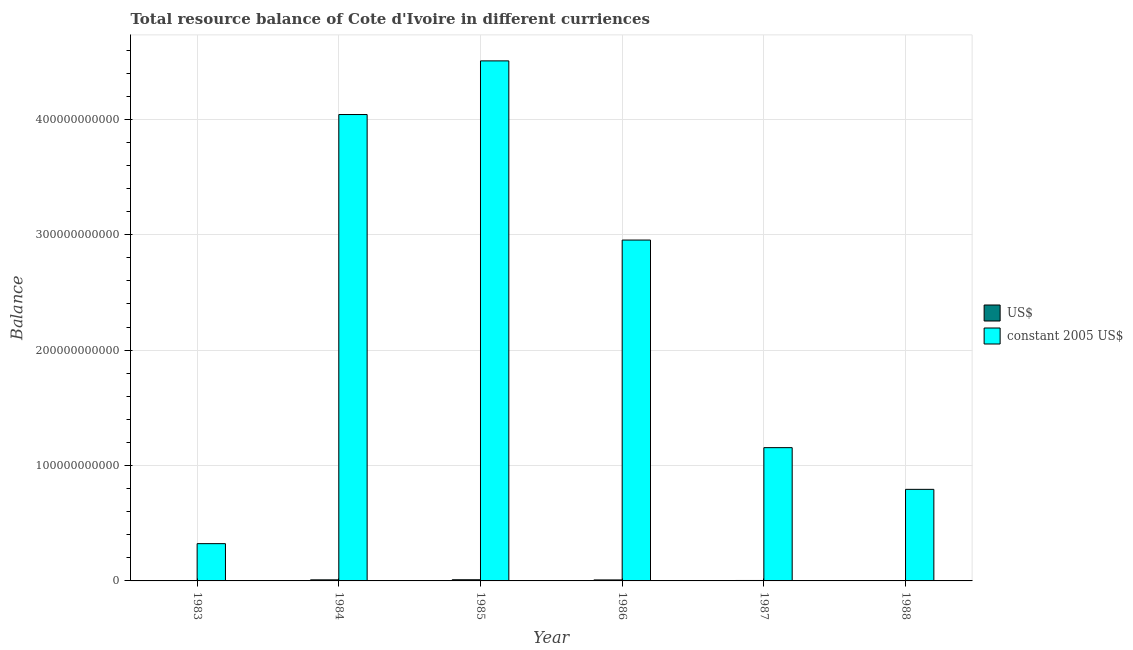How many different coloured bars are there?
Make the answer very short. 2. How many groups of bars are there?
Keep it short and to the point. 6. Are the number of bars on each tick of the X-axis equal?
Keep it short and to the point. Yes. How many bars are there on the 1st tick from the left?
Provide a short and direct response. 2. What is the label of the 1st group of bars from the left?
Make the answer very short. 1983. What is the resource balance in us$ in 1983?
Provide a succinct answer. 8.48e+07. Across all years, what is the maximum resource balance in constant us$?
Keep it short and to the point. 4.51e+11. Across all years, what is the minimum resource balance in constant us$?
Offer a very short reply. 3.23e+1. In which year was the resource balance in constant us$ minimum?
Offer a very short reply. 1983. What is the total resource balance in constant us$ in the graph?
Offer a terse response. 1.38e+12. What is the difference between the resource balance in constant us$ in 1983 and that in 1987?
Your response must be concise. -8.32e+1. What is the difference between the resource balance in us$ in 1986 and the resource balance in constant us$ in 1983?
Offer a terse response. 7.68e+08. What is the average resource balance in us$ per year?
Provide a succinct answer. 5.86e+08. What is the ratio of the resource balance in constant us$ in 1985 to that in 1986?
Provide a succinct answer. 1.53. Is the resource balance in us$ in 1984 less than that in 1986?
Your answer should be very brief. No. Is the difference between the resource balance in us$ in 1984 and 1987 greater than the difference between the resource balance in constant us$ in 1984 and 1987?
Provide a short and direct response. No. What is the difference between the highest and the second highest resource balance in us$?
Ensure brevity in your answer.  7.82e+07. What is the difference between the highest and the lowest resource balance in us$?
Your answer should be very brief. 9.18e+08. Is the sum of the resource balance in constant us$ in 1984 and 1985 greater than the maximum resource balance in us$ across all years?
Provide a short and direct response. Yes. What does the 1st bar from the left in 1984 represents?
Your response must be concise. US$. What does the 2nd bar from the right in 1987 represents?
Provide a short and direct response. US$. How many bars are there?
Provide a short and direct response. 12. How many years are there in the graph?
Keep it short and to the point. 6. What is the difference between two consecutive major ticks on the Y-axis?
Provide a succinct answer. 1.00e+11. Are the values on the major ticks of Y-axis written in scientific E-notation?
Make the answer very short. No. How many legend labels are there?
Offer a very short reply. 2. How are the legend labels stacked?
Keep it short and to the point. Vertical. What is the title of the graph?
Offer a very short reply. Total resource balance of Cote d'Ivoire in different curriences. What is the label or title of the Y-axis?
Your answer should be compact. Balance. What is the Balance in US$ in 1983?
Your answer should be very brief. 8.48e+07. What is the Balance of constant 2005 US$ in 1983?
Your answer should be very brief. 3.23e+1. What is the Balance in US$ in 1984?
Offer a very short reply. 9.25e+08. What is the Balance of constant 2005 US$ in 1984?
Keep it short and to the point. 4.04e+11. What is the Balance of US$ in 1985?
Make the answer very short. 1.00e+09. What is the Balance of constant 2005 US$ in 1985?
Your response must be concise. 4.51e+11. What is the Balance in US$ in 1986?
Your answer should be compact. 8.53e+08. What is the Balance of constant 2005 US$ in 1986?
Your response must be concise. 2.95e+11. What is the Balance in US$ in 1987?
Your response must be concise. 3.84e+08. What is the Balance in constant 2005 US$ in 1987?
Make the answer very short. 1.15e+11. What is the Balance of US$ in 1988?
Offer a very short reply. 2.66e+08. What is the Balance of constant 2005 US$ in 1988?
Ensure brevity in your answer.  7.94e+1. Across all years, what is the maximum Balance of US$?
Your response must be concise. 1.00e+09. Across all years, what is the maximum Balance in constant 2005 US$?
Ensure brevity in your answer.  4.51e+11. Across all years, what is the minimum Balance in US$?
Provide a succinct answer. 8.48e+07. Across all years, what is the minimum Balance of constant 2005 US$?
Give a very brief answer. 3.23e+1. What is the total Balance in US$ in the graph?
Ensure brevity in your answer.  3.52e+09. What is the total Balance of constant 2005 US$ in the graph?
Your response must be concise. 1.38e+12. What is the difference between the Balance of US$ in 1983 and that in 1984?
Your response must be concise. -8.40e+08. What is the difference between the Balance of constant 2005 US$ in 1983 and that in 1984?
Provide a short and direct response. -3.72e+11. What is the difference between the Balance in US$ in 1983 and that in 1985?
Give a very brief answer. -9.18e+08. What is the difference between the Balance in constant 2005 US$ in 1983 and that in 1985?
Provide a short and direct response. -4.18e+11. What is the difference between the Balance in US$ in 1983 and that in 1986?
Provide a short and direct response. -7.68e+08. What is the difference between the Balance of constant 2005 US$ in 1983 and that in 1986?
Keep it short and to the point. -2.63e+11. What is the difference between the Balance of US$ in 1983 and that in 1987?
Keep it short and to the point. -3.00e+08. What is the difference between the Balance of constant 2005 US$ in 1983 and that in 1987?
Keep it short and to the point. -8.32e+1. What is the difference between the Balance in US$ in 1983 and that in 1988?
Ensure brevity in your answer.  -1.82e+08. What is the difference between the Balance in constant 2005 US$ in 1983 and that in 1988?
Your answer should be compact. -4.71e+1. What is the difference between the Balance of US$ in 1984 and that in 1985?
Ensure brevity in your answer.  -7.82e+07. What is the difference between the Balance in constant 2005 US$ in 1984 and that in 1985?
Offer a terse response. -4.65e+1. What is the difference between the Balance in US$ in 1984 and that in 1986?
Your answer should be compact. 7.20e+07. What is the difference between the Balance of constant 2005 US$ in 1984 and that in 1986?
Your answer should be compact. 1.09e+11. What is the difference between the Balance of US$ in 1984 and that in 1987?
Offer a very short reply. 5.41e+08. What is the difference between the Balance of constant 2005 US$ in 1984 and that in 1987?
Ensure brevity in your answer.  2.89e+11. What is the difference between the Balance of US$ in 1984 and that in 1988?
Provide a succinct answer. 6.59e+08. What is the difference between the Balance in constant 2005 US$ in 1984 and that in 1988?
Keep it short and to the point. 3.25e+11. What is the difference between the Balance in US$ in 1985 and that in 1986?
Give a very brief answer. 1.50e+08. What is the difference between the Balance of constant 2005 US$ in 1985 and that in 1986?
Offer a very short reply. 1.55e+11. What is the difference between the Balance in US$ in 1985 and that in 1987?
Your answer should be very brief. 6.19e+08. What is the difference between the Balance of constant 2005 US$ in 1985 and that in 1987?
Your response must be concise. 3.35e+11. What is the difference between the Balance in US$ in 1985 and that in 1988?
Provide a short and direct response. 7.37e+08. What is the difference between the Balance of constant 2005 US$ in 1985 and that in 1988?
Offer a very short reply. 3.71e+11. What is the difference between the Balance in US$ in 1986 and that in 1987?
Make the answer very short. 4.69e+08. What is the difference between the Balance of constant 2005 US$ in 1986 and that in 1987?
Ensure brevity in your answer.  1.80e+11. What is the difference between the Balance in US$ in 1986 and that in 1988?
Provide a short and direct response. 5.87e+08. What is the difference between the Balance in constant 2005 US$ in 1986 and that in 1988?
Give a very brief answer. 2.16e+11. What is the difference between the Balance of US$ in 1987 and that in 1988?
Keep it short and to the point. 1.18e+08. What is the difference between the Balance in constant 2005 US$ in 1987 and that in 1988?
Your answer should be very brief. 3.61e+1. What is the difference between the Balance in US$ in 1983 and the Balance in constant 2005 US$ in 1984?
Your answer should be very brief. -4.04e+11. What is the difference between the Balance in US$ in 1983 and the Balance in constant 2005 US$ in 1985?
Provide a succinct answer. -4.51e+11. What is the difference between the Balance in US$ in 1983 and the Balance in constant 2005 US$ in 1986?
Offer a terse response. -2.95e+11. What is the difference between the Balance in US$ in 1983 and the Balance in constant 2005 US$ in 1987?
Your response must be concise. -1.15e+11. What is the difference between the Balance in US$ in 1983 and the Balance in constant 2005 US$ in 1988?
Provide a short and direct response. -7.93e+1. What is the difference between the Balance of US$ in 1984 and the Balance of constant 2005 US$ in 1985?
Keep it short and to the point. -4.50e+11. What is the difference between the Balance of US$ in 1984 and the Balance of constant 2005 US$ in 1986?
Give a very brief answer. -2.94e+11. What is the difference between the Balance in US$ in 1984 and the Balance in constant 2005 US$ in 1987?
Make the answer very short. -1.15e+11. What is the difference between the Balance in US$ in 1984 and the Balance in constant 2005 US$ in 1988?
Offer a very short reply. -7.84e+1. What is the difference between the Balance in US$ in 1985 and the Balance in constant 2005 US$ in 1986?
Offer a terse response. -2.94e+11. What is the difference between the Balance in US$ in 1985 and the Balance in constant 2005 US$ in 1987?
Your answer should be very brief. -1.14e+11. What is the difference between the Balance of US$ in 1985 and the Balance of constant 2005 US$ in 1988?
Keep it short and to the point. -7.84e+1. What is the difference between the Balance in US$ in 1986 and the Balance in constant 2005 US$ in 1987?
Offer a very short reply. -1.15e+11. What is the difference between the Balance of US$ in 1986 and the Balance of constant 2005 US$ in 1988?
Your answer should be compact. -7.85e+1. What is the difference between the Balance in US$ in 1987 and the Balance in constant 2005 US$ in 1988?
Offer a very short reply. -7.90e+1. What is the average Balance in US$ per year?
Your answer should be very brief. 5.86e+08. What is the average Balance of constant 2005 US$ per year?
Your answer should be compact. 2.30e+11. In the year 1983, what is the difference between the Balance of US$ and Balance of constant 2005 US$?
Your response must be concise. -3.22e+1. In the year 1984, what is the difference between the Balance of US$ and Balance of constant 2005 US$?
Your answer should be very brief. -4.03e+11. In the year 1985, what is the difference between the Balance in US$ and Balance in constant 2005 US$?
Make the answer very short. -4.50e+11. In the year 1986, what is the difference between the Balance in US$ and Balance in constant 2005 US$?
Your response must be concise. -2.95e+11. In the year 1987, what is the difference between the Balance of US$ and Balance of constant 2005 US$?
Give a very brief answer. -1.15e+11. In the year 1988, what is the difference between the Balance in US$ and Balance in constant 2005 US$?
Your answer should be very brief. -7.91e+1. What is the ratio of the Balance of US$ in 1983 to that in 1984?
Provide a short and direct response. 0.09. What is the ratio of the Balance of constant 2005 US$ in 1983 to that in 1984?
Keep it short and to the point. 0.08. What is the ratio of the Balance of US$ in 1983 to that in 1985?
Your response must be concise. 0.08. What is the ratio of the Balance in constant 2005 US$ in 1983 to that in 1985?
Your response must be concise. 0.07. What is the ratio of the Balance of US$ in 1983 to that in 1986?
Offer a very short reply. 0.1. What is the ratio of the Balance of constant 2005 US$ in 1983 to that in 1986?
Your answer should be compact. 0.11. What is the ratio of the Balance in US$ in 1983 to that in 1987?
Provide a succinct answer. 0.22. What is the ratio of the Balance of constant 2005 US$ in 1983 to that in 1987?
Provide a succinct answer. 0.28. What is the ratio of the Balance of US$ in 1983 to that in 1988?
Offer a terse response. 0.32. What is the ratio of the Balance in constant 2005 US$ in 1983 to that in 1988?
Offer a terse response. 0.41. What is the ratio of the Balance of US$ in 1984 to that in 1985?
Your response must be concise. 0.92. What is the ratio of the Balance in constant 2005 US$ in 1984 to that in 1985?
Ensure brevity in your answer.  0.9. What is the ratio of the Balance of US$ in 1984 to that in 1986?
Ensure brevity in your answer.  1.08. What is the ratio of the Balance in constant 2005 US$ in 1984 to that in 1986?
Your answer should be very brief. 1.37. What is the ratio of the Balance of US$ in 1984 to that in 1987?
Your answer should be very brief. 2.41. What is the ratio of the Balance of constant 2005 US$ in 1984 to that in 1987?
Offer a very short reply. 3.5. What is the ratio of the Balance in US$ in 1984 to that in 1988?
Your answer should be compact. 3.47. What is the ratio of the Balance of constant 2005 US$ in 1984 to that in 1988?
Keep it short and to the point. 5.09. What is the ratio of the Balance in US$ in 1985 to that in 1986?
Ensure brevity in your answer.  1.18. What is the ratio of the Balance of constant 2005 US$ in 1985 to that in 1986?
Your answer should be very brief. 1.53. What is the ratio of the Balance of US$ in 1985 to that in 1987?
Ensure brevity in your answer.  2.61. What is the ratio of the Balance in constant 2005 US$ in 1985 to that in 1987?
Offer a terse response. 3.9. What is the ratio of the Balance of US$ in 1985 to that in 1988?
Ensure brevity in your answer.  3.77. What is the ratio of the Balance in constant 2005 US$ in 1985 to that in 1988?
Your answer should be very brief. 5.68. What is the ratio of the Balance of US$ in 1986 to that in 1987?
Ensure brevity in your answer.  2.22. What is the ratio of the Balance in constant 2005 US$ in 1986 to that in 1987?
Your answer should be very brief. 2.56. What is the ratio of the Balance of US$ in 1986 to that in 1988?
Your response must be concise. 3.2. What is the ratio of the Balance of constant 2005 US$ in 1986 to that in 1988?
Provide a succinct answer. 3.72. What is the ratio of the Balance in US$ in 1987 to that in 1988?
Keep it short and to the point. 1.44. What is the ratio of the Balance in constant 2005 US$ in 1987 to that in 1988?
Offer a very short reply. 1.46. What is the difference between the highest and the second highest Balance of US$?
Provide a succinct answer. 7.82e+07. What is the difference between the highest and the second highest Balance of constant 2005 US$?
Your answer should be compact. 4.65e+1. What is the difference between the highest and the lowest Balance of US$?
Keep it short and to the point. 9.18e+08. What is the difference between the highest and the lowest Balance of constant 2005 US$?
Give a very brief answer. 4.18e+11. 